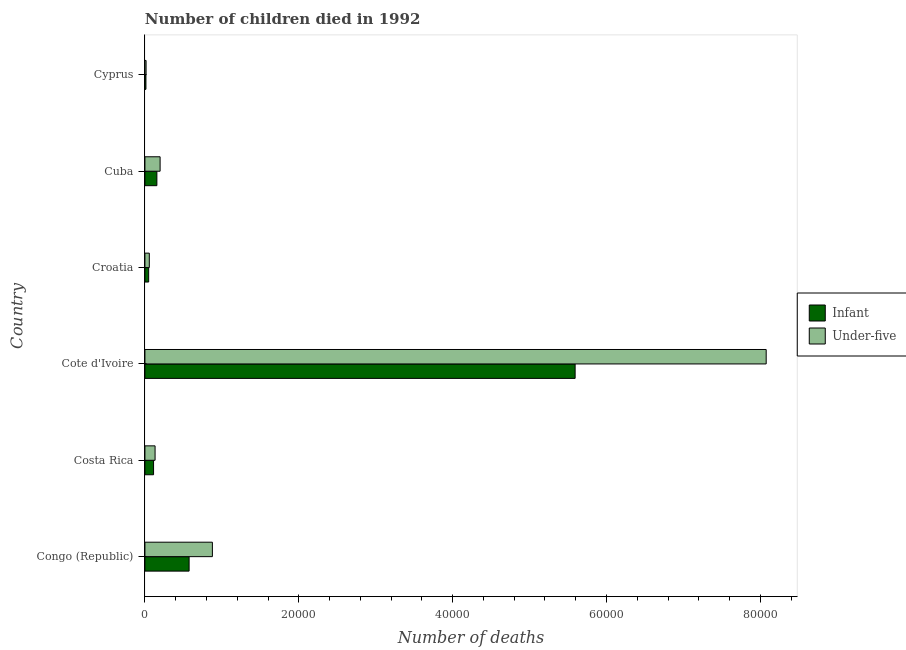How many groups of bars are there?
Your answer should be very brief. 6. Are the number of bars per tick equal to the number of legend labels?
Give a very brief answer. Yes. Are the number of bars on each tick of the Y-axis equal?
Offer a terse response. Yes. How many bars are there on the 4th tick from the bottom?
Your answer should be compact. 2. What is the label of the 2nd group of bars from the top?
Give a very brief answer. Cuba. In how many cases, is the number of bars for a given country not equal to the number of legend labels?
Make the answer very short. 0. What is the number of under-five deaths in Croatia?
Provide a succinct answer. 572. Across all countries, what is the maximum number of infant deaths?
Provide a short and direct response. 5.59e+04. Across all countries, what is the minimum number of under-five deaths?
Make the answer very short. 150. In which country was the number of under-five deaths maximum?
Offer a terse response. Cote d'Ivoire. In which country was the number of infant deaths minimum?
Give a very brief answer. Cyprus. What is the total number of under-five deaths in the graph?
Offer a terse response. 9.35e+04. What is the difference between the number of infant deaths in Costa Rica and that in Croatia?
Provide a succinct answer. 636. What is the difference between the number of under-five deaths in Costa Rica and the number of infant deaths in Congo (Republic)?
Your answer should be compact. -4422. What is the average number of infant deaths per country?
Offer a very short reply. 1.08e+04. What is the difference between the number of infant deaths and number of under-five deaths in Croatia?
Your answer should be compact. -84. What is the ratio of the number of under-five deaths in Costa Rica to that in Cyprus?
Offer a very short reply. 8.81. What is the difference between the highest and the second highest number of under-five deaths?
Your answer should be compact. 7.20e+04. What is the difference between the highest and the lowest number of under-five deaths?
Offer a terse response. 8.06e+04. In how many countries, is the number of under-five deaths greater than the average number of under-five deaths taken over all countries?
Give a very brief answer. 1. Is the sum of the number of under-five deaths in Congo (Republic) and Costa Rica greater than the maximum number of infant deaths across all countries?
Make the answer very short. No. What does the 2nd bar from the top in Congo (Republic) represents?
Your response must be concise. Infant. What does the 2nd bar from the bottom in Cuba represents?
Your answer should be very brief. Under-five. How many bars are there?
Keep it short and to the point. 12. Are all the bars in the graph horizontal?
Provide a succinct answer. Yes. How many countries are there in the graph?
Offer a terse response. 6. What is the difference between two consecutive major ticks on the X-axis?
Offer a very short reply. 2.00e+04. Does the graph contain grids?
Offer a very short reply. No. Where does the legend appear in the graph?
Make the answer very short. Center right. How many legend labels are there?
Offer a very short reply. 2. What is the title of the graph?
Keep it short and to the point. Number of children died in 1992. What is the label or title of the X-axis?
Your answer should be very brief. Number of deaths. What is the Number of deaths in Infant in Congo (Republic)?
Provide a short and direct response. 5743. What is the Number of deaths in Under-five in Congo (Republic)?
Provide a short and direct response. 8770. What is the Number of deaths of Infant in Costa Rica?
Provide a short and direct response. 1124. What is the Number of deaths in Under-five in Costa Rica?
Your answer should be compact. 1321. What is the Number of deaths in Infant in Cote d'Ivoire?
Offer a terse response. 5.59e+04. What is the Number of deaths in Under-five in Cote d'Ivoire?
Your answer should be very brief. 8.08e+04. What is the Number of deaths in Infant in Croatia?
Provide a short and direct response. 488. What is the Number of deaths in Under-five in Croatia?
Your answer should be very brief. 572. What is the Number of deaths in Infant in Cuba?
Give a very brief answer. 1554. What is the Number of deaths in Under-five in Cuba?
Offer a very short reply. 1974. What is the Number of deaths of Infant in Cyprus?
Provide a succinct answer. 133. What is the Number of deaths in Under-five in Cyprus?
Keep it short and to the point. 150. Across all countries, what is the maximum Number of deaths of Infant?
Make the answer very short. 5.59e+04. Across all countries, what is the maximum Number of deaths in Under-five?
Make the answer very short. 8.08e+04. Across all countries, what is the minimum Number of deaths of Infant?
Keep it short and to the point. 133. Across all countries, what is the minimum Number of deaths of Under-five?
Keep it short and to the point. 150. What is the total Number of deaths in Infant in the graph?
Your response must be concise. 6.50e+04. What is the total Number of deaths in Under-five in the graph?
Your response must be concise. 9.35e+04. What is the difference between the Number of deaths in Infant in Congo (Republic) and that in Costa Rica?
Your answer should be compact. 4619. What is the difference between the Number of deaths in Under-five in Congo (Republic) and that in Costa Rica?
Give a very brief answer. 7449. What is the difference between the Number of deaths in Infant in Congo (Republic) and that in Cote d'Ivoire?
Offer a very short reply. -5.02e+04. What is the difference between the Number of deaths of Under-five in Congo (Republic) and that in Cote d'Ivoire?
Provide a succinct answer. -7.20e+04. What is the difference between the Number of deaths in Infant in Congo (Republic) and that in Croatia?
Give a very brief answer. 5255. What is the difference between the Number of deaths in Under-five in Congo (Republic) and that in Croatia?
Keep it short and to the point. 8198. What is the difference between the Number of deaths of Infant in Congo (Republic) and that in Cuba?
Offer a very short reply. 4189. What is the difference between the Number of deaths in Under-five in Congo (Republic) and that in Cuba?
Make the answer very short. 6796. What is the difference between the Number of deaths in Infant in Congo (Republic) and that in Cyprus?
Your answer should be very brief. 5610. What is the difference between the Number of deaths in Under-five in Congo (Republic) and that in Cyprus?
Your answer should be compact. 8620. What is the difference between the Number of deaths of Infant in Costa Rica and that in Cote d'Ivoire?
Provide a succinct answer. -5.48e+04. What is the difference between the Number of deaths of Under-five in Costa Rica and that in Cote d'Ivoire?
Ensure brevity in your answer.  -7.94e+04. What is the difference between the Number of deaths in Infant in Costa Rica and that in Croatia?
Your response must be concise. 636. What is the difference between the Number of deaths of Under-five in Costa Rica and that in Croatia?
Keep it short and to the point. 749. What is the difference between the Number of deaths in Infant in Costa Rica and that in Cuba?
Offer a very short reply. -430. What is the difference between the Number of deaths of Under-five in Costa Rica and that in Cuba?
Your answer should be very brief. -653. What is the difference between the Number of deaths of Infant in Costa Rica and that in Cyprus?
Your answer should be very brief. 991. What is the difference between the Number of deaths in Under-five in Costa Rica and that in Cyprus?
Offer a terse response. 1171. What is the difference between the Number of deaths in Infant in Cote d'Ivoire and that in Croatia?
Give a very brief answer. 5.54e+04. What is the difference between the Number of deaths of Under-five in Cote d'Ivoire and that in Croatia?
Your answer should be very brief. 8.02e+04. What is the difference between the Number of deaths of Infant in Cote d'Ivoire and that in Cuba?
Provide a succinct answer. 5.44e+04. What is the difference between the Number of deaths in Under-five in Cote d'Ivoire and that in Cuba?
Make the answer very short. 7.88e+04. What is the difference between the Number of deaths of Infant in Cote d'Ivoire and that in Cyprus?
Give a very brief answer. 5.58e+04. What is the difference between the Number of deaths in Under-five in Cote d'Ivoire and that in Cyprus?
Offer a very short reply. 8.06e+04. What is the difference between the Number of deaths of Infant in Croatia and that in Cuba?
Give a very brief answer. -1066. What is the difference between the Number of deaths of Under-five in Croatia and that in Cuba?
Give a very brief answer. -1402. What is the difference between the Number of deaths of Infant in Croatia and that in Cyprus?
Provide a short and direct response. 355. What is the difference between the Number of deaths of Under-five in Croatia and that in Cyprus?
Keep it short and to the point. 422. What is the difference between the Number of deaths of Infant in Cuba and that in Cyprus?
Provide a succinct answer. 1421. What is the difference between the Number of deaths in Under-five in Cuba and that in Cyprus?
Give a very brief answer. 1824. What is the difference between the Number of deaths of Infant in Congo (Republic) and the Number of deaths of Under-five in Costa Rica?
Your answer should be very brief. 4422. What is the difference between the Number of deaths of Infant in Congo (Republic) and the Number of deaths of Under-five in Cote d'Ivoire?
Provide a succinct answer. -7.50e+04. What is the difference between the Number of deaths in Infant in Congo (Republic) and the Number of deaths in Under-five in Croatia?
Make the answer very short. 5171. What is the difference between the Number of deaths in Infant in Congo (Republic) and the Number of deaths in Under-five in Cuba?
Keep it short and to the point. 3769. What is the difference between the Number of deaths in Infant in Congo (Republic) and the Number of deaths in Under-five in Cyprus?
Ensure brevity in your answer.  5593. What is the difference between the Number of deaths of Infant in Costa Rica and the Number of deaths of Under-five in Cote d'Ivoire?
Your response must be concise. -7.96e+04. What is the difference between the Number of deaths in Infant in Costa Rica and the Number of deaths in Under-five in Croatia?
Offer a very short reply. 552. What is the difference between the Number of deaths of Infant in Costa Rica and the Number of deaths of Under-five in Cuba?
Provide a short and direct response. -850. What is the difference between the Number of deaths of Infant in Costa Rica and the Number of deaths of Under-five in Cyprus?
Ensure brevity in your answer.  974. What is the difference between the Number of deaths of Infant in Cote d'Ivoire and the Number of deaths of Under-five in Croatia?
Your answer should be very brief. 5.53e+04. What is the difference between the Number of deaths of Infant in Cote d'Ivoire and the Number of deaths of Under-five in Cuba?
Make the answer very short. 5.39e+04. What is the difference between the Number of deaths of Infant in Cote d'Ivoire and the Number of deaths of Under-five in Cyprus?
Provide a succinct answer. 5.58e+04. What is the difference between the Number of deaths in Infant in Croatia and the Number of deaths in Under-five in Cuba?
Your answer should be compact. -1486. What is the difference between the Number of deaths of Infant in Croatia and the Number of deaths of Under-five in Cyprus?
Make the answer very short. 338. What is the difference between the Number of deaths in Infant in Cuba and the Number of deaths in Under-five in Cyprus?
Offer a very short reply. 1404. What is the average Number of deaths of Infant per country?
Ensure brevity in your answer.  1.08e+04. What is the average Number of deaths in Under-five per country?
Your answer should be very brief. 1.56e+04. What is the difference between the Number of deaths in Infant and Number of deaths in Under-five in Congo (Republic)?
Make the answer very short. -3027. What is the difference between the Number of deaths in Infant and Number of deaths in Under-five in Costa Rica?
Your answer should be very brief. -197. What is the difference between the Number of deaths of Infant and Number of deaths of Under-five in Cote d'Ivoire?
Provide a succinct answer. -2.48e+04. What is the difference between the Number of deaths of Infant and Number of deaths of Under-five in Croatia?
Provide a succinct answer. -84. What is the difference between the Number of deaths of Infant and Number of deaths of Under-five in Cuba?
Give a very brief answer. -420. What is the ratio of the Number of deaths of Infant in Congo (Republic) to that in Costa Rica?
Offer a terse response. 5.11. What is the ratio of the Number of deaths of Under-five in Congo (Republic) to that in Costa Rica?
Ensure brevity in your answer.  6.64. What is the ratio of the Number of deaths in Infant in Congo (Republic) to that in Cote d'Ivoire?
Offer a terse response. 0.1. What is the ratio of the Number of deaths in Under-five in Congo (Republic) to that in Cote d'Ivoire?
Your response must be concise. 0.11. What is the ratio of the Number of deaths of Infant in Congo (Republic) to that in Croatia?
Your response must be concise. 11.77. What is the ratio of the Number of deaths in Under-five in Congo (Republic) to that in Croatia?
Ensure brevity in your answer.  15.33. What is the ratio of the Number of deaths of Infant in Congo (Republic) to that in Cuba?
Give a very brief answer. 3.7. What is the ratio of the Number of deaths of Under-five in Congo (Republic) to that in Cuba?
Ensure brevity in your answer.  4.44. What is the ratio of the Number of deaths of Infant in Congo (Republic) to that in Cyprus?
Provide a succinct answer. 43.18. What is the ratio of the Number of deaths of Under-five in Congo (Republic) to that in Cyprus?
Ensure brevity in your answer.  58.47. What is the ratio of the Number of deaths of Infant in Costa Rica to that in Cote d'Ivoire?
Your answer should be compact. 0.02. What is the ratio of the Number of deaths of Under-five in Costa Rica to that in Cote d'Ivoire?
Offer a terse response. 0.02. What is the ratio of the Number of deaths in Infant in Costa Rica to that in Croatia?
Ensure brevity in your answer.  2.3. What is the ratio of the Number of deaths in Under-five in Costa Rica to that in Croatia?
Your answer should be compact. 2.31. What is the ratio of the Number of deaths of Infant in Costa Rica to that in Cuba?
Keep it short and to the point. 0.72. What is the ratio of the Number of deaths of Under-five in Costa Rica to that in Cuba?
Offer a terse response. 0.67. What is the ratio of the Number of deaths in Infant in Costa Rica to that in Cyprus?
Make the answer very short. 8.45. What is the ratio of the Number of deaths in Under-five in Costa Rica to that in Cyprus?
Offer a terse response. 8.81. What is the ratio of the Number of deaths in Infant in Cote d'Ivoire to that in Croatia?
Offer a terse response. 114.59. What is the ratio of the Number of deaths of Under-five in Cote d'Ivoire to that in Croatia?
Your answer should be very brief. 141.18. What is the ratio of the Number of deaths of Infant in Cote d'Ivoire to that in Cuba?
Your answer should be very brief. 35.99. What is the ratio of the Number of deaths in Under-five in Cote d'Ivoire to that in Cuba?
Your answer should be very brief. 40.91. What is the ratio of the Number of deaths in Infant in Cote d'Ivoire to that in Cyprus?
Offer a terse response. 420.46. What is the ratio of the Number of deaths of Under-five in Cote d'Ivoire to that in Cyprus?
Your response must be concise. 538.37. What is the ratio of the Number of deaths of Infant in Croatia to that in Cuba?
Your answer should be compact. 0.31. What is the ratio of the Number of deaths of Under-five in Croatia to that in Cuba?
Ensure brevity in your answer.  0.29. What is the ratio of the Number of deaths in Infant in Croatia to that in Cyprus?
Ensure brevity in your answer.  3.67. What is the ratio of the Number of deaths in Under-five in Croatia to that in Cyprus?
Offer a very short reply. 3.81. What is the ratio of the Number of deaths in Infant in Cuba to that in Cyprus?
Offer a very short reply. 11.68. What is the ratio of the Number of deaths of Under-five in Cuba to that in Cyprus?
Your response must be concise. 13.16. What is the difference between the highest and the second highest Number of deaths in Infant?
Your answer should be compact. 5.02e+04. What is the difference between the highest and the second highest Number of deaths of Under-five?
Offer a terse response. 7.20e+04. What is the difference between the highest and the lowest Number of deaths in Infant?
Keep it short and to the point. 5.58e+04. What is the difference between the highest and the lowest Number of deaths in Under-five?
Provide a short and direct response. 8.06e+04. 